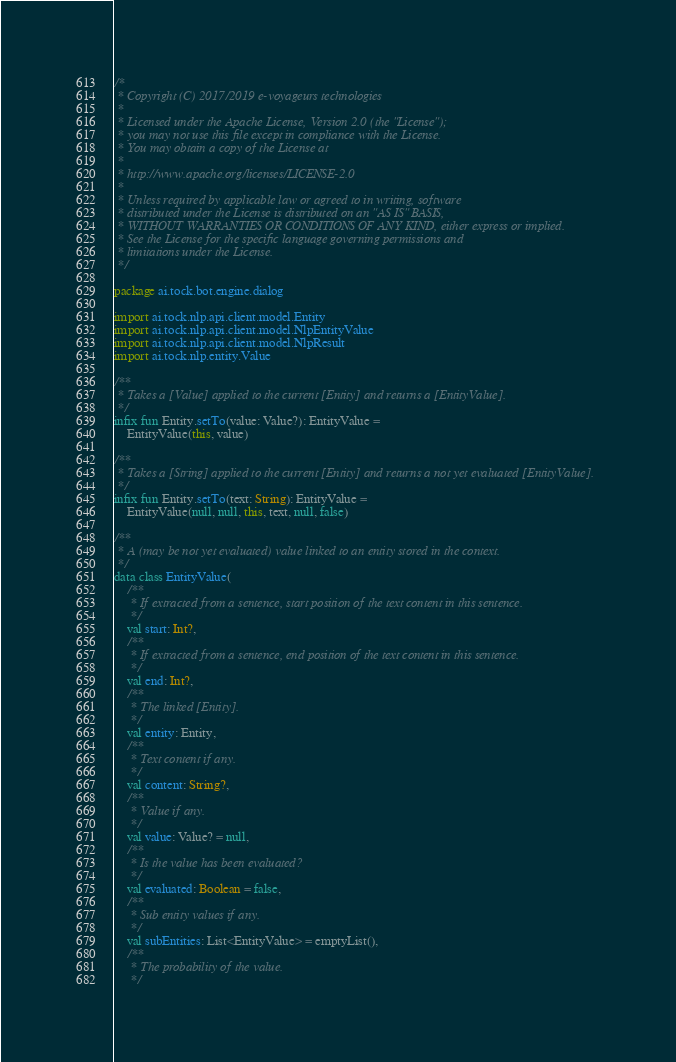Convert code to text. <code><loc_0><loc_0><loc_500><loc_500><_Kotlin_>/*
 * Copyright (C) 2017/2019 e-voyageurs technologies
 *
 * Licensed under the Apache License, Version 2.0 (the "License");
 * you may not use this file except in compliance with the License.
 * You may obtain a copy of the License at
 *
 * http://www.apache.org/licenses/LICENSE-2.0
 *
 * Unless required by applicable law or agreed to in writing, software
 * distributed under the License is distributed on an "AS IS" BASIS,
 * WITHOUT WARRANTIES OR CONDITIONS OF ANY KIND, either express or implied.
 * See the License for the specific language governing permissions and
 * limitations under the License.
 */

package ai.tock.bot.engine.dialog

import ai.tock.nlp.api.client.model.Entity
import ai.tock.nlp.api.client.model.NlpEntityValue
import ai.tock.nlp.api.client.model.NlpResult
import ai.tock.nlp.entity.Value

/**
 * Takes a [Value] applied to the current [Entity] and returns a [EntityValue].
 */
infix fun Entity.setTo(value: Value?): EntityValue =
    EntityValue(this, value)

/**
 * Takes a [String] applied to the current [Entity] and returns a not yet evaluated [EntityValue].
 */
infix fun Entity.setTo(text: String): EntityValue =
    EntityValue(null, null, this, text, null, false)

/**
 * A (may be not yet evaluated) value linked to an entity stored in the context.
 */
data class EntityValue(
    /**
     * If extracted from a sentence, start position of the text content in this sentence.
     */
    val start: Int?,
    /**
     * If extracted from a sentence, end position of the text content in this sentence.
     */
    val end: Int?,
    /**
     * The linked [Entity].
     */
    val entity: Entity,
    /**
     * Text content if any.
     */
    val content: String?,
    /**
     * Value if any.
     */
    val value: Value? = null,
    /**
     * Is the value has been evaluated?
     */
    val evaluated: Boolean = false,
    /**
     * Sub entity values if any.
     */
    val subEntities: List<EntityValue> = emptyList(),
    /**
     * The probability of the value.
     */</code> 